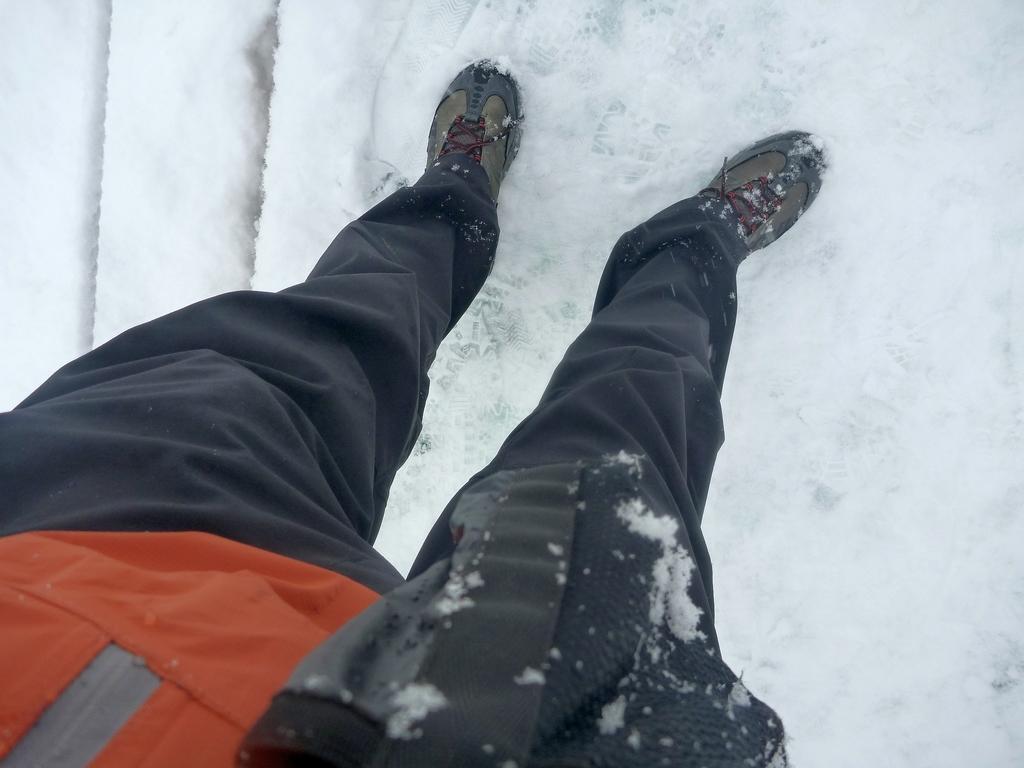Please provide a concise description of this image. In this image I can see a person standing on the snow, he is wearing shoes. 